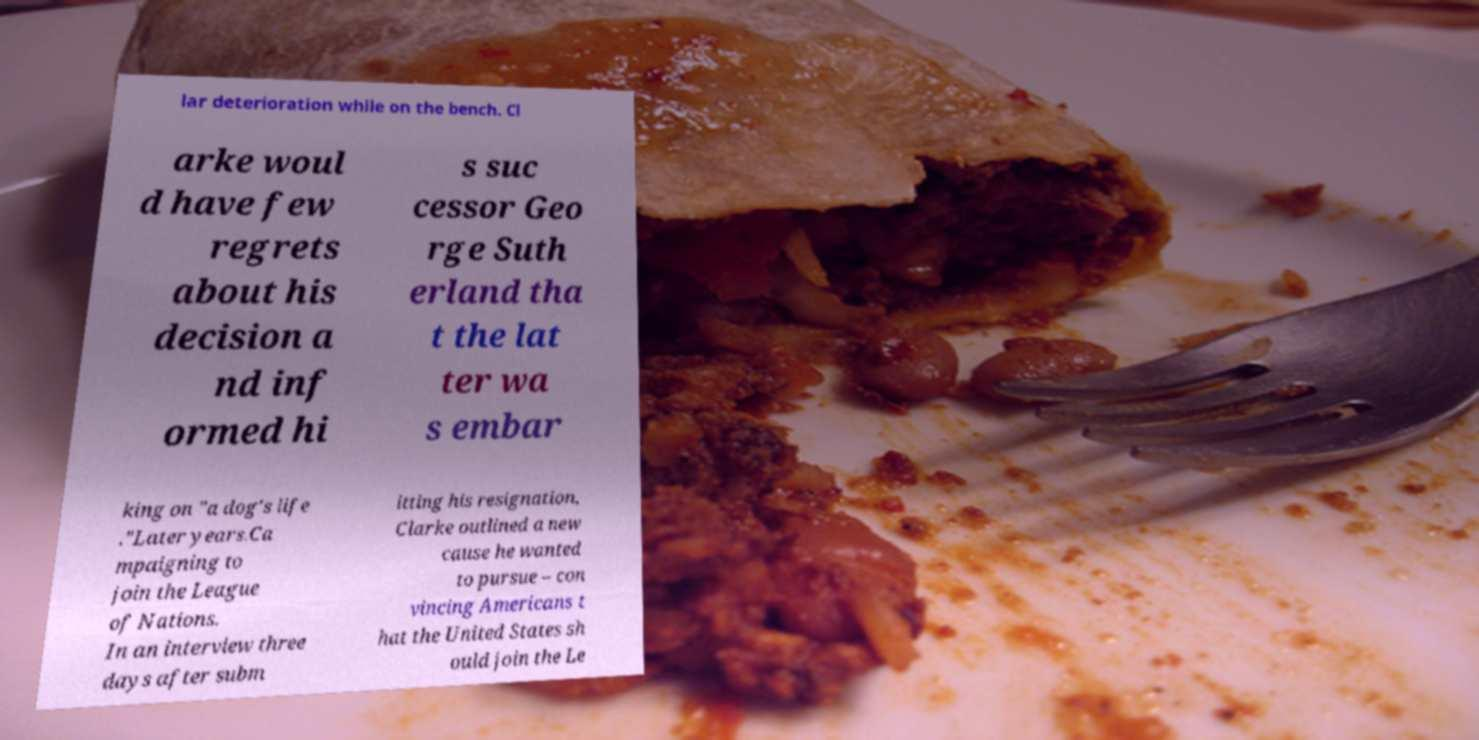Can you read and provide the text displayed in the image?This photo seems to have some interesting text. Can you extract and type it out for me? lar deterioration while on the bench. Cl arke woul d have few regrets about his decision a nd inf ormed hi s suc cessor Geo rge Suth erland tha t the lat ter wa s embar king on "a dog's life ."Later years.Ca mpaigning to join the League of Nations. In an interview three days after subm itting his resignation, Clarke outlined a new cause he wanted to pursue – con vincing Americans t hat the United States sh ould join the Le 